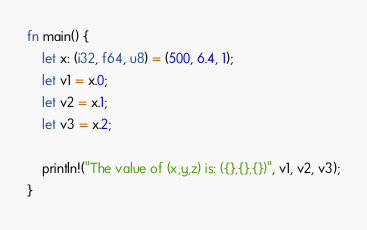<code> <loc_0><loc_0><loc_500><loc_500><_Rust_>fn main() {
    let x: (i32, f64, u8) = (500, 6.4, 1);
    let v1 = x.0;
    let v2 = x.1;
    let v3 = x.2;

    println!("The value of (x,y,z) is: ({},{},{})", v1, v2, v3);
}
</code> 